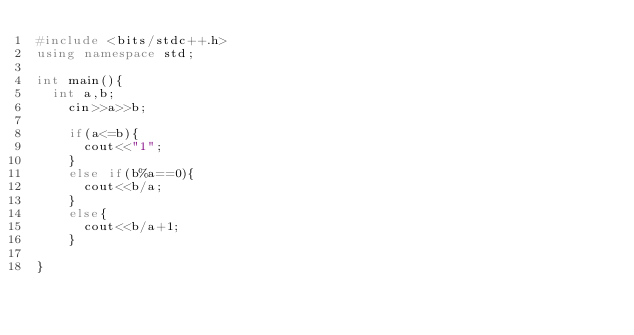<code> <loc_0><loc_0><loc_500><loc_500><_C++_>#include <bits/stdc++.h>
using namespace std;

int main(){
	int a,b;
  	cin>>a>>b;
  	
  	if(a<=b){
    	cout<<"1";
    }
  	else if(b%a==0){
    	cout<<b/a;
    }
  	else{
     	cout<<b/a+1; 
    }
  
}</code> 